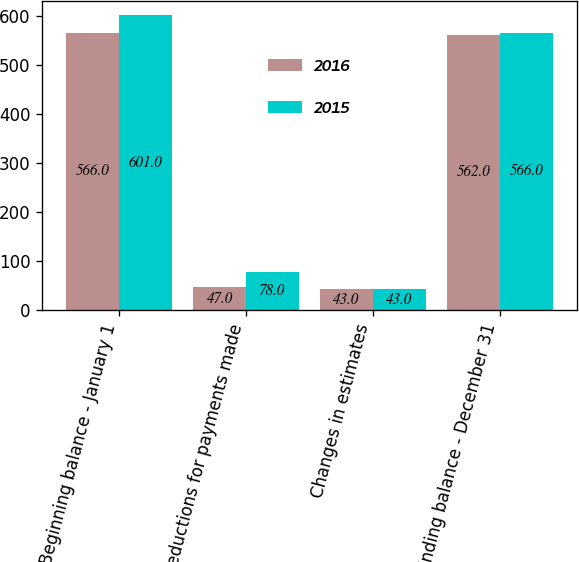<chart> <loc_0><loc_0><loc_500><loc_500><stacked_bar_chart><ecel><fcel>Beginning balance - January 1<fcel>Reductions for payments made<fcel>Changes in estimates<fcel>Ending balance - December 31<nl><fcel>2016<fcel>566<fcel>47<fcel>43<fcel>562<nl><fcel>2015<fcel>601<fcel>78<fcel>43<fcel>566<nl></chart> 